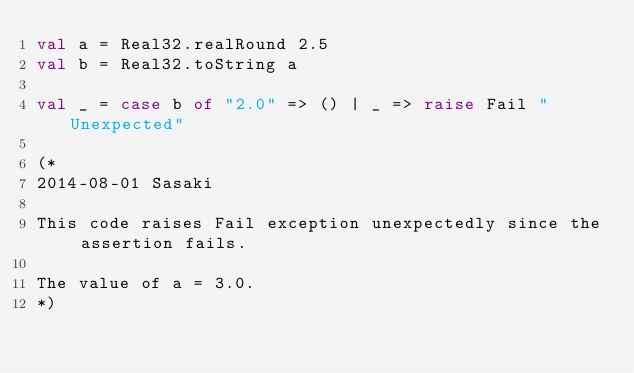<code> <loc_0><loc_0><loc_500><loc_500><_SML_>val a = Real32.realRound 2.5
val b = Real32.toString a

val _ = case b of "2.0" => () | _ => raise Fail "Unexpected"

(*
2014-08-01 Sasaki

This code raises Fail exception unexpectedly since the assertion fails.

The value of a = 3.0.
*)
</code> 